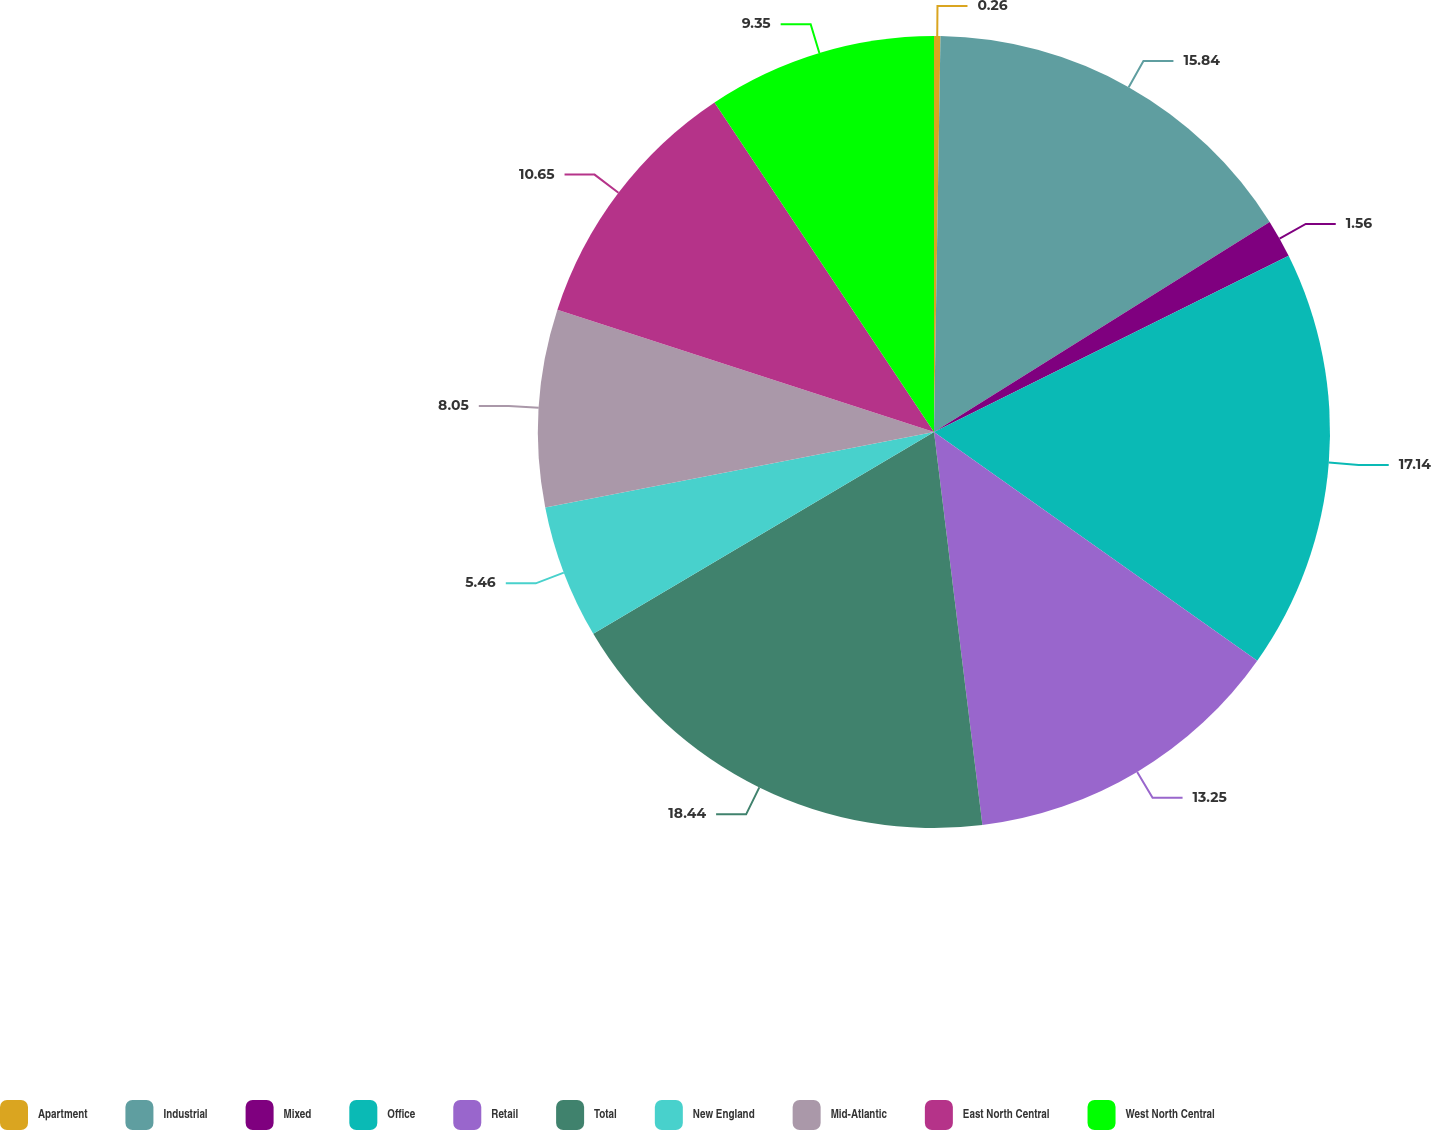Convert chart. <chart><loc_0><loc_0><loc_500><loc_500><pie_chart><fcel>Apartment<fcel>Industrial<fcel>Mixed<fcel>Office<fcel>Retail<fcel>Total<fcel>New England<fcel>Mid-Atlantic<fcel>East North Central<fcel>West North Central<nl><fcel>0.26%<fcel>15.84%<fcel>1.56%<fcel>17.14%<fcel>13.25%<fcel>18.44%<fcel>5.46%<fcel>8.05%<fcel>10.65%<fcel>9.35%<nl></chart> 